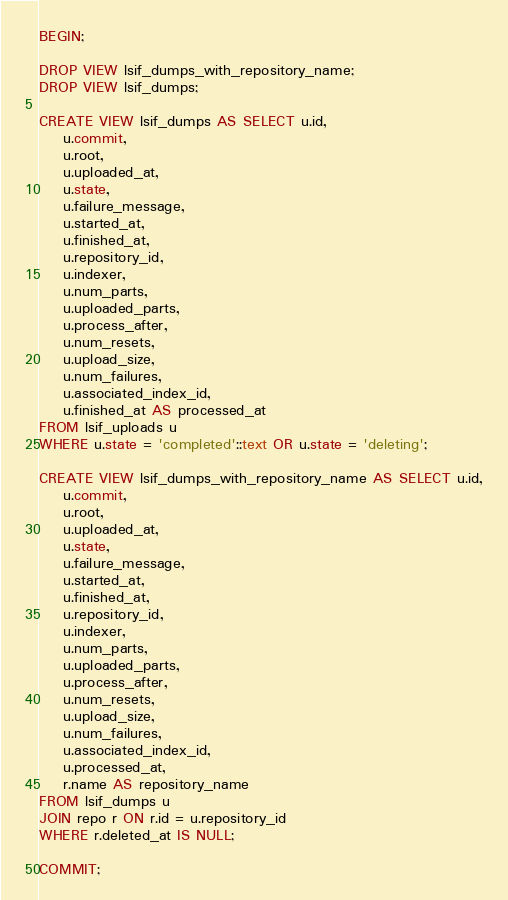Convert code to text. <code><loc_0><loc_0><loc_500><loc_500><_SQL_>BEGIN;

DROP VIEW lsif_dumps_with_repository_name;
DROP VIEW lsif_dumps;

CREATE VIEW lsif_dumps AS SELECT u.id,
    u.commit,
    u.root,
    u.uploaded_at,
    u.state,
    u.failure_message,
    u.started_at,
    u.finished_at,
    u.repository_id,
    u.indexer,
    u.num_parts,
    u.uploaded_parts,
    u.process_after,
    u.num_resets,
    u.upload_size,
    u.num_failures,
    u.associated_index_id,
    u.finished_at AS processed_at
FROM lsif_uploads u
WHERE u.state = 'completed'::text OR u.state = 'deleting';

CREATE VIEW lsif_dumps_with_repository_name AS SELECT u.id,
    u.commit,
    u.root,
    u.uploaded_at,
    u.state,
    u.failure_message,
    u.started_at,
    u.finished_at,
    u.repository_id,
    u.indexer,
    u.num_parts,
    u.uploaded_parts,
    u.process_after,
    u.num_resets,
    u.upload_size,
    u.num_failures,
    u.associated_index_id,
    u.processed_at,
    r.name AS repository_name
FROM lsif_dumps u
JOIN repo r ON r.id = u.repository_id
WHERE r.deleted_at IS NULL;

COMMIT;
</code> 